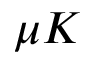Convert formula to latex. <formula><loc_0><loc_0><loc_500><loc_500>\mu K</formula> 